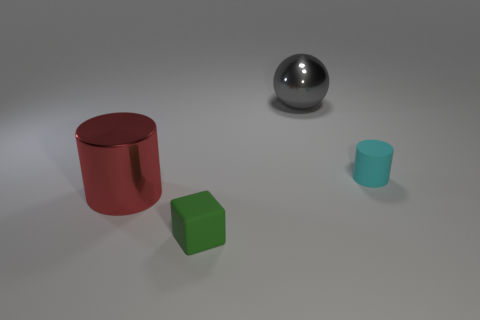Add 1 small cyan things. How many objects exist? 5 Subtract all spheres. How many objects are left? 3 Subtract all cylinders. Subtract all gray metal things. How many objects are left? 1 Add 4 green things. How many green things are left? 5 Add 2 small cyan rubber cylinders. How many small cyan rubber cylinders exist? 3 Subtract 0 yellow cubes. How many objects are left? 4 